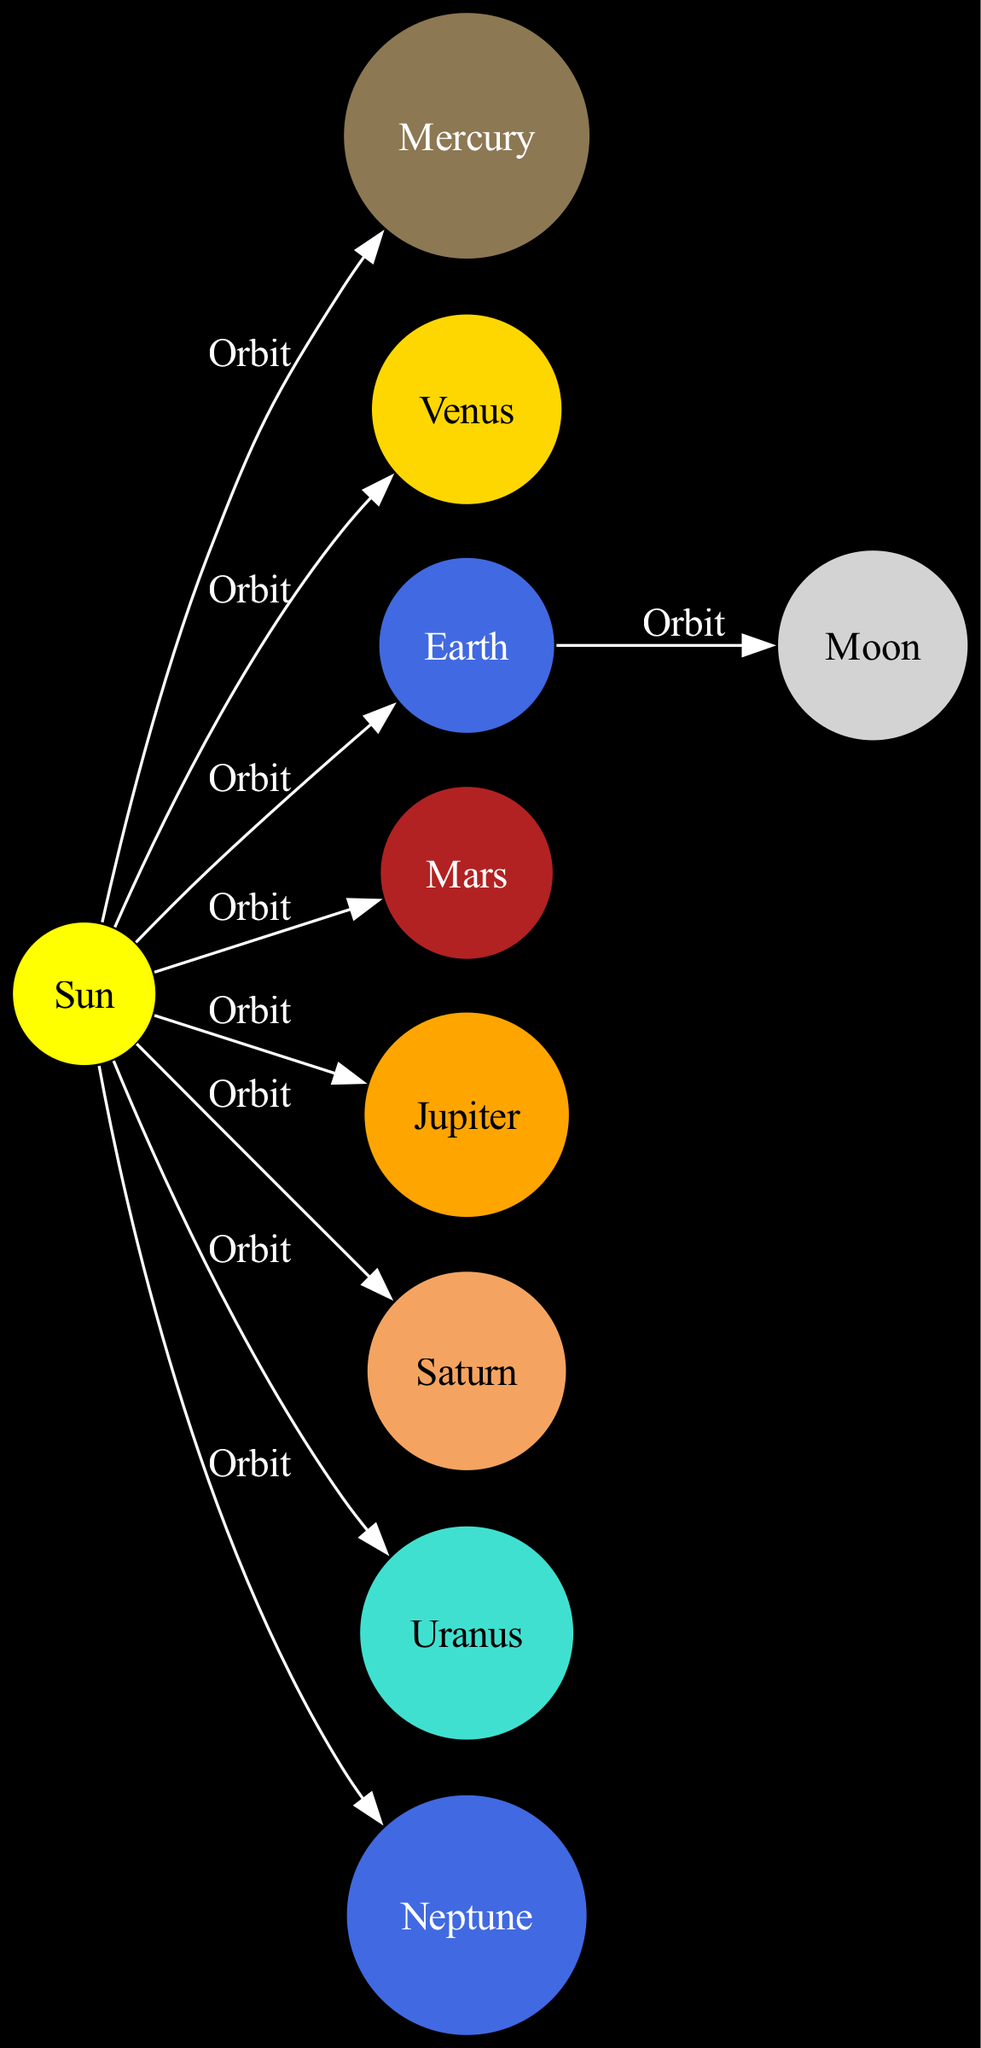What is the central star of the solar system? The diagram identifies "Sun" as the central star, marking it as the primary gravitational source for the solar system.
Answer: Sun How many planets are shown in the diagram? By counting the nodes labeled as planets, there are eight distinct planets represented in the diagram.
Answer: 8 Which planet has a highly elliptical orbit? The description of Mercury in the diagram indicates that it "has a highly elliptical orbit," making it the answer.
Answer: Mercury What is the relationship between Earth and the Moon? The diagram shows an edge labeled "Orbit," indicating that the gravitational pull from Earth keeps the Moon in its orbit around it.
Answer: Orbit Which planet is known for its prominent ring system? The node for Saturn specifies that it is "known for its prominent ring system," confirming it as the answer.
Answer: Saturn Which planet has the strongest magnetic field? The diagram states that Jupiter is "the largest planet in the solar system" and specifies that it also has "a strong magnetic field," thus confirming it as the answer.
Answer: Jupiter How many moons does Mars have? The description for Mars mentions it has "two small moons, Phobos and Deimos," leading to this numerical answer.
Answer: 2 Which planet is the farthest from the Sun? The diagram's description for Neptune states that it is "the farthest planet from the Sun," providing a clear answer.
Answer: Neptune Which planet is described as having extreme seasonal variations? The description for Uranus notes its unique tilt, which causes "extreme seasonal variations," making it the answer.
Answer: Uranus 